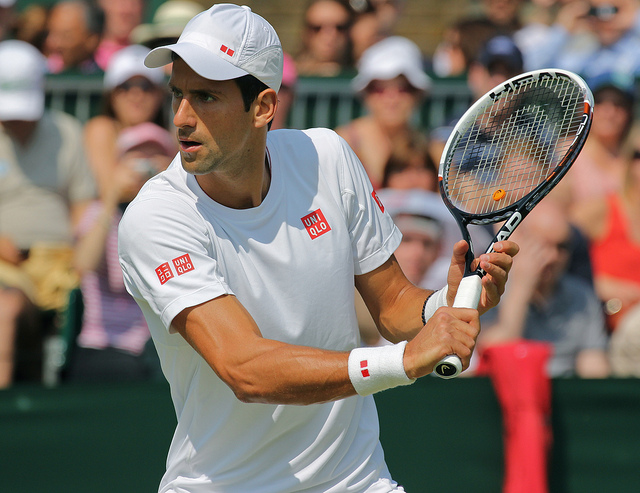Please transcribe the text in this image. UNI QLO UNI QLO AD HEAD 01 